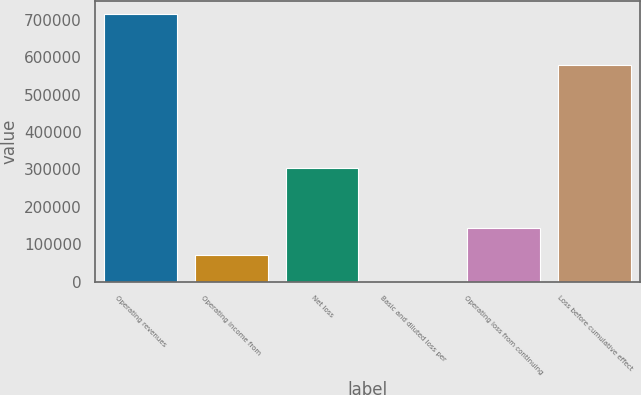<chart> <loc_0><loc_0><loc_500><loc_500><bar_chart><fcel>Operating revenues<fcel>Operating income from<fcel>Net loss<fcel>Basic and diluted loss per<fcel>Operating loss from continuing<fcel>Loss before cumulative effect<nl><fcel>715144<fcel>71515.7<fcel>303417<fcel>1.46<fcel>143030<fcel>579261<nl></chart> 